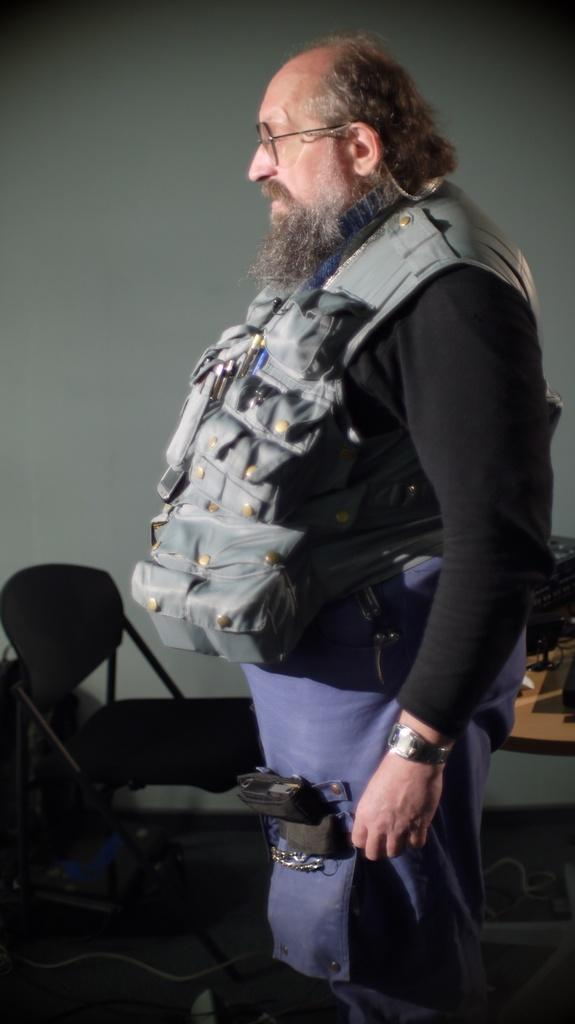What is the main subject of the image? There is a person standing in the image. Can you describe the person's appearance? The person is wearing spectacles. What furniture is visible in the image? There is a chair in the image. What can be seen on the table in the image? There is a table with objects in the image. What is visible in the background of the image? There is a wall in the background of the image. What type of plough is being used by the person in the image? There is no plough present in the image; it features a person standing with spectacles, a chair, a table with objects, and a wall in the background. What kind of vessel is the person holding in the image? There is no vessel present in the image; it only features a person standing with spectacles, a chair, a table with objects, and a wall in the background. 